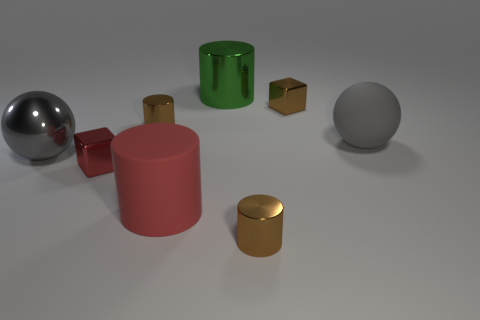What is the big red thing made of?
Offer a terse response. Rubber. How many other things are there of the same shape as the big red thing?
Provide a succinct answer. 3. What is the size of the green metal cylinder?
Your response must be concise. Large. What is the size of the brown shiny thing that is right of the red cylinder and behind the red metal cube?
Keep it short and to the point. Small. The big gray object that is to the left of the tiny red object has what shape?
Offer a terse response. Sphere. Is the material of the big green object the same as the big gray ball to the left of the brown metal block?
Make the answer very short. Yes. Do the green metallic thing and the gray rubber thing have the same shape?
Provide a succinct answer. No. There is another big object that is the same shape as the red matte object; what is its material?
Offer a terse response. Metal. What is the color of the large object that is both left of the green object and to the right of the big gray metal object?
Provide a succinct answer. Red. The matte sphere has what color?
Keep it short and to the point. Gray. 